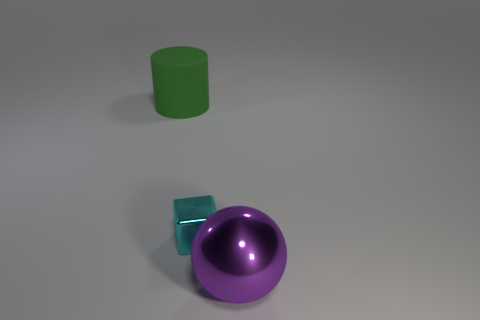Add 3 red cylinders. How many objects exist? 6 Subtract all cubes. How many objects are left? 2 Subtract all large red blocks. Subtract all big purple spheres. How many objects are left? 2 Add 1 purple objects. How many purple objects are left? 2 Add 3 small brown cubes. How many small brown cubes exist? 3 Subtract 0 yellow cylinders. How many objects are left? 3 